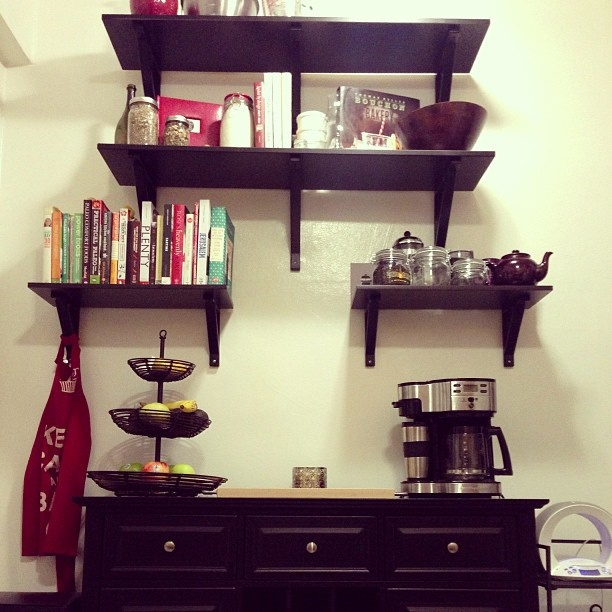Describe the objects in this image and their specific colors. I can see book in lightyellow, gray, darkgray, beige, and brown tones, bowl in lightyellow, black, maroon, brown, and gray tones, bowl in lightyellow, purple, and brown tones, book in lightyellow, darkgray, gray, and turquoise tones, and bowl in lightyellow, darkgray, beige, and gray tones in this image. 